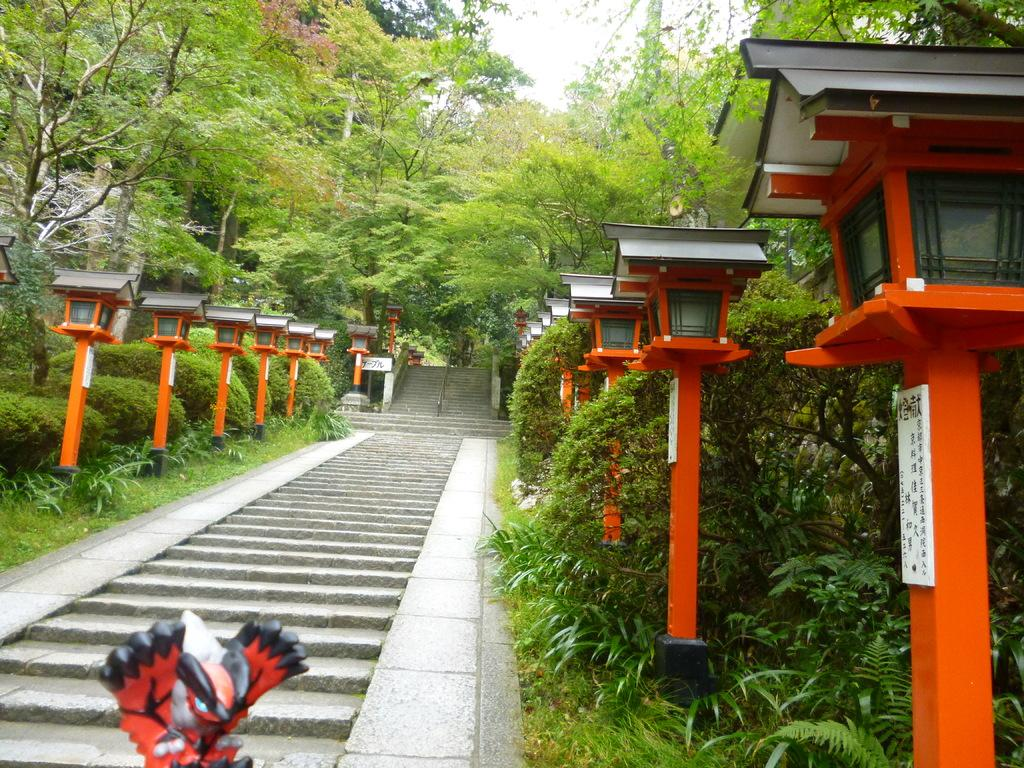What type of structures can be seen in the image? There are poles and staircases in the image. What type of illumination is present in the image? There are lights in the image. What type of vegetation can be seen in the image? There are plants, trees, and grass in the image. What type of artwork is visible in the image? There is a sculpture in the background of the image. What part of the natural environment is visible in the image? The sky is visible in the image. Can you see a mitten being used to hit the sculpture in the image? There is no mitten or hammer present in the image, and therefore no such activity can be observed. 